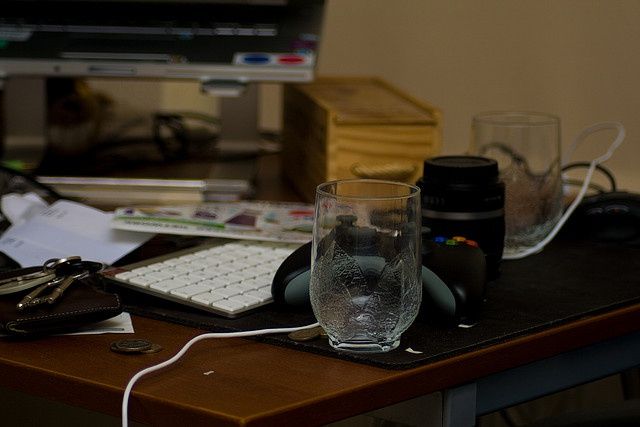Describe the objects in this image and their specific colors. I can see dining table in black, maroon, olive, and gray tones, cup in black, gray, and olive tones, tv in black and purple tones, cup in black and gray tones, and keyboard in black, darkgray, gray, and darkgreen tones in this image. 